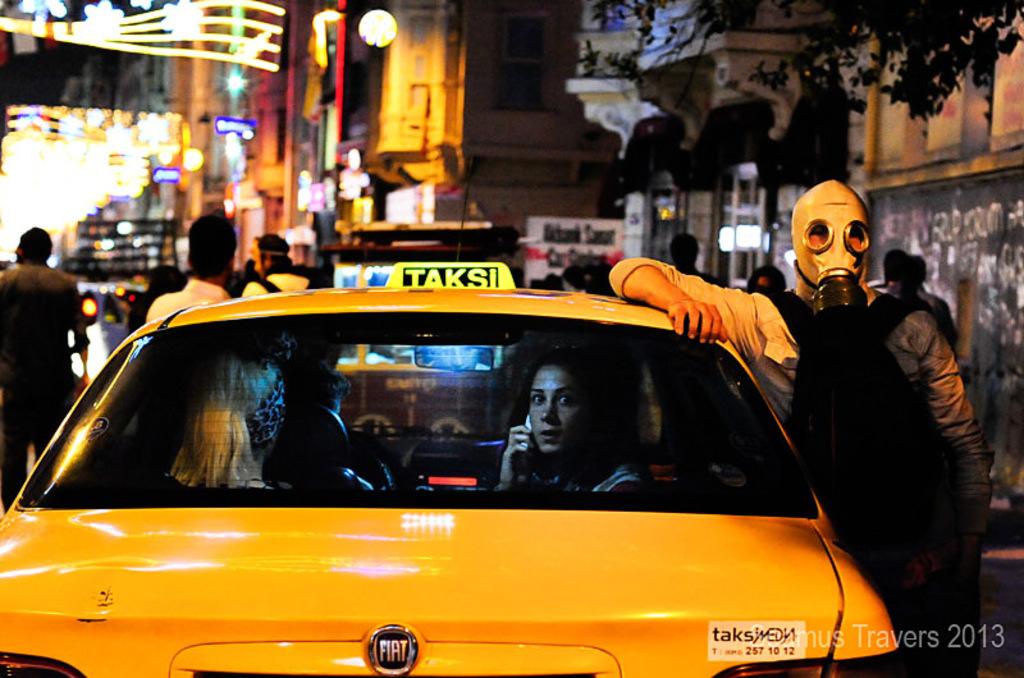What year does the faded time stamp say?
Give a very brief answer. 2013. What does the lighted sign on top of the cab say?
Your answer should be compact. Taksi. 